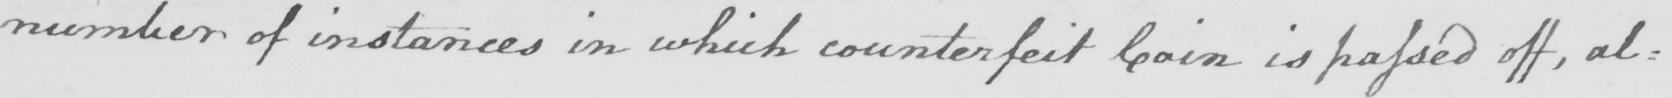Can you read and transcribe this handwriting? number of instances in which counterfeit Coin is passed off , al= 